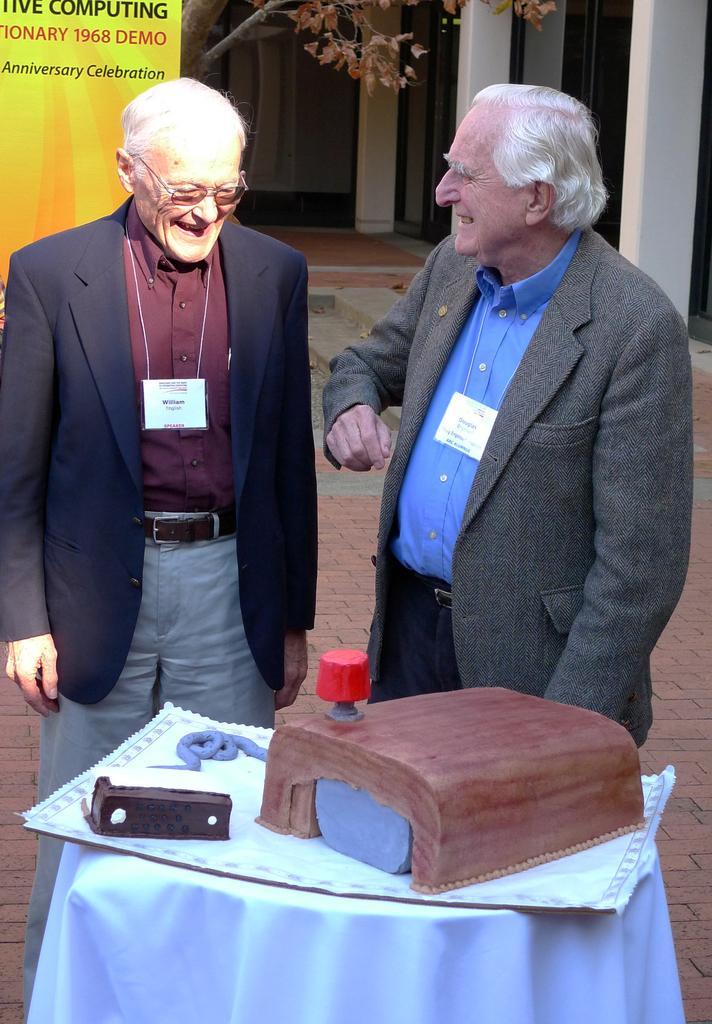Describe this image in one or two sentences. In this image I can see a two persons standing. On the table there are some object. At the background there is a building. 